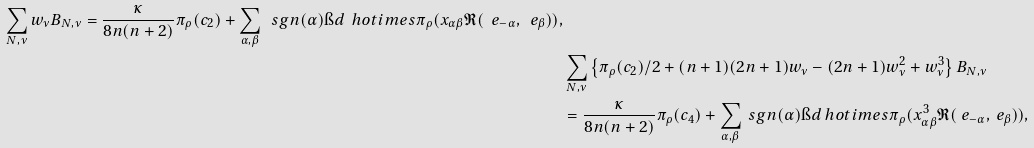Convert formula to latex. <formula><loc_0><loc_0><loc_500><loc_500>\sum _ { N , \nu } w _ { \nu } B _ { N , \nu } = \frac { \kappa } { 8 n ( n + 2 ) } \pi _ { \rho } ( c _ { 2 } ) + \sum _ { \alpha , \beta } \ s g n ( \alpha ) \i d \ h o t i m e s \pi _ { \rho } ( x _ { \alpha \beta } \mathfrak { R } ( \ e _ { - \alpha } , \ e _ { \beta } ) ) , \\ & \sum _ { N , \nu } \left \{ \pi _ { \rho } ( c _ { 2 } ) / 2 + ( n + 1 ) ( 2 n + 1 ) w _ { \nu } - ( 2 n + 1 ) w _ { \nu } ^ { 2 } + w _ { \nu } ^ { 3 } \right \} B _ { N , \nu } \\ & = \frac { \kappa } { 8 n ( n + 2 ) } \pi _ { \rho } ( c _ { 4 } ) + \sum _ { \alpha , \beta } \ s g n ( \alpha ) \i d \ h o t i m e s \pi _ { \rho } ( x _ { \alpha \beta } ^ { 3 } \mathfrak { R } ( \ e _ { - \alpha } , \ e _ { \beta } ) ) ,</formula> 